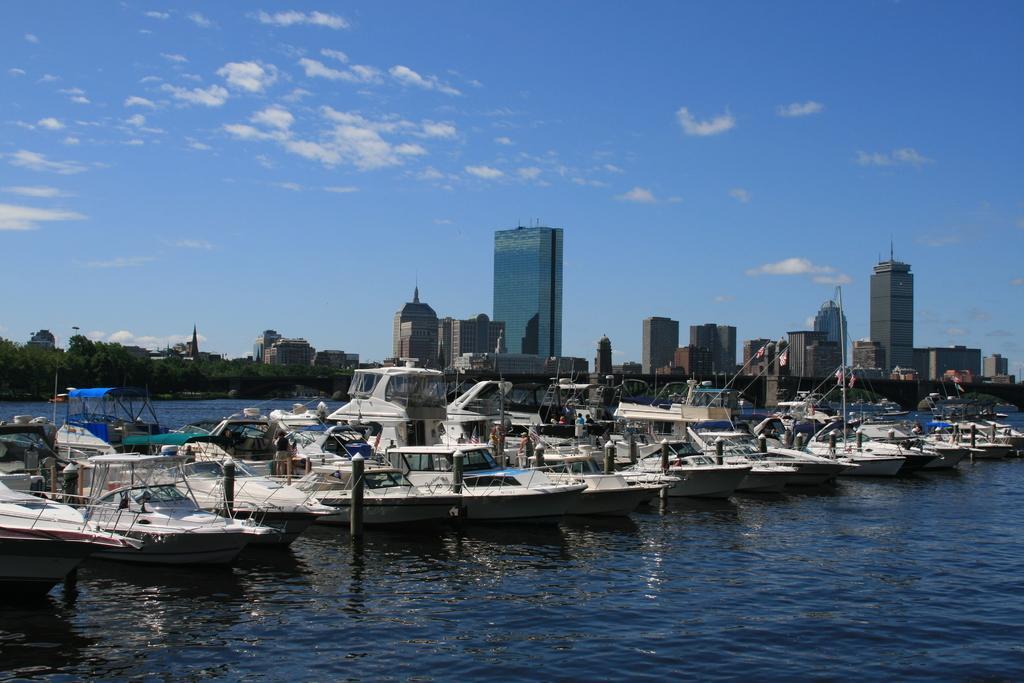In one or two sentences, can you explain what this image depicts? As we can see in the image there is water, boats, buildings, trees, sky and clouds. 